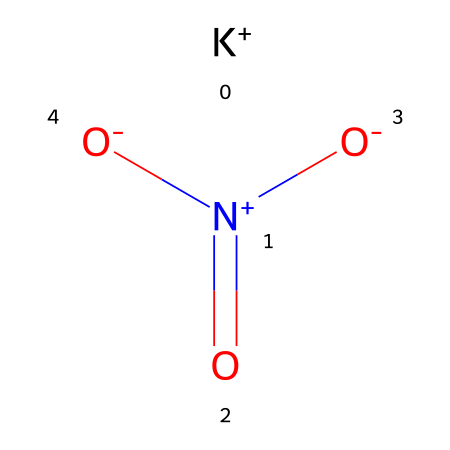What is the name of the chemical represented by this SMILES? The SMILES notation consists of the elements potassium (K), nitrogen (N), and oxygen (O) in a specified arrangement indicating a nitrate compound. This aligns with the well-known fertilizer chemical potassium nitrate.
Answer: potassium nitrate How many oxygen atoms are present in the chemical structure? The SMILES representation shows two negatively charged oxygen atoms bonded to nitrogen and one neutral oxygen, indicating there are three oxygen atoms in total.
Answer: three What is the oxidation state of nitrogen in this compound? In potassium nitrate, nitrogen is bonded in such a way that it exhibits an oxidation state of +5, as it is bonded to three oxygen atoms where one is positively charged and the other two carry negative charges.
Answer: +5 Which ion is represented by the symbol "K+" in this structure? The "K+" ion is the cation present in potassium nitrate, specifically representing potassium, which is an essential nutrient in fertilizers.
Answer: potassium ion What type of compound does potassium nitrate belong to? Potassium nitrate is classified under the category of oxidizers in chemistry, as it can donate oxygen to support the combustion of other materials, aiding in its role as a fertilizer.
Answer: oxidizer How many total atoms are there in the molecular composition? By counting K (1), N (1), and O (3), we find a total of 5 atoms in the molecule, making it a relatively simple inorganic compound.
Answer: five 